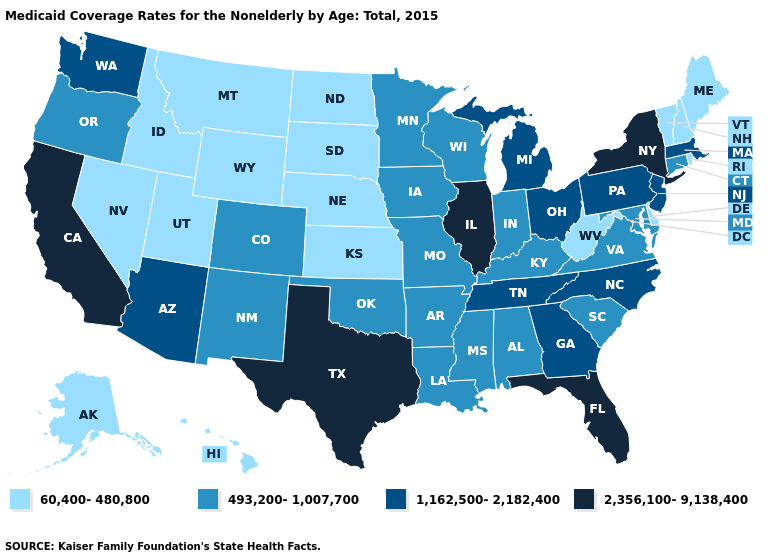Name the states that have a value in the range 493,200-1,007,700?
Keep it brief. Alabama, Arkansas, Colorado, Connecticut, Indiana, Iowa, Kentucky, Louisiana, Maryland, Minnesota, Mississippi, Missouri, New Mexico, Oklahoma, Oregon, South Carolina, Virginia, Wisconsin. Which states have the lowest value in the USA?
Give a very brief answer. Alaska, Delaware, Hawaii, Idaho, Kansas, Maine, Montana, Nebraska, Nevada, New Hampshire, North Dakota, Rhode Island, South Dakota, Utah, Vermont, West Virginia, Wyoming. What is the value of Michigan?
Concise answer only. 1,162,500-2,182,400. Name the states that have a value in the range 1,162,500-2,182,400?
Keep it brief. Arizona, Georgia, Massachusetts, Michigan, New Jersey, North Carolina, Ohio, Pennsylvania, Tennessee, Washington. How many symbols are there in the legend?
Give a very brief answer. 4. Is the legend a continuous bar?
Answer briefly. No. What is the value of South Dakota?
Quick response, please. 60,400-480,800. Does Wisconsin have a lower value than Arizona?
Write a very short answer. Yes. What is the lowest value in states that border Ohio?
Give a very brief answer. 60,400-480,800. Does West Virginia have the lowest value in the South?
Short answer required. Yes. Among the states that border Kentucky , which have the highest value?
Keep it brief. Illinois. What is the value of Illinois?
Give a very brief answer. 2,356,100-9,138,400. Does Washington have a lower value than Illinois?
Short answer required. Yes. Name the states that have a value in the range 1,162,500-2,182,400?
Concise answer only. Arizona, Georgia, Massachusetts, Michigan, New Jersey, North Carolina, Ohio, Pennsylvania, Tennessee, Washington. Among the states that border Connecticut , which have the highest value?
Answer briefly. New York. 